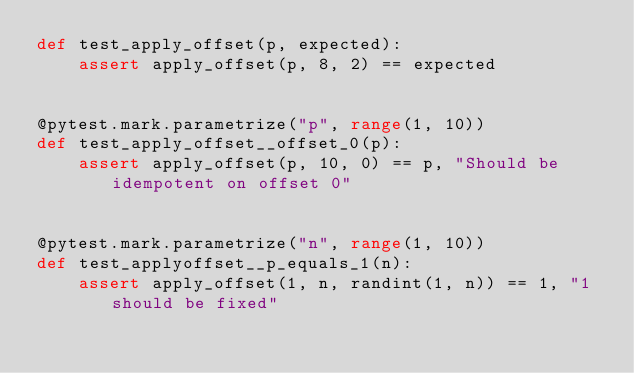Convert code to text. <code><loc_0><loc_0><loc_500><loc_500><_Python_>def test_apply_offset(p, expected):
    assert apply_offset(p, 8, 2) == expected


@pytest.mark.parametrize("p", range(1, 10))
def test_apply_offset__offset_0(p):
    assert apply_offset(p, 10, 0) == p, "Should be idempotent on offset 0"


@pytest.mark.parametrize("n", range(1, 10))
def test_applyoffset__p_equals_1(n):
    assert apply_offset(1, n, randint(1, n)) == 1, "1 should be fixed"
</code> 